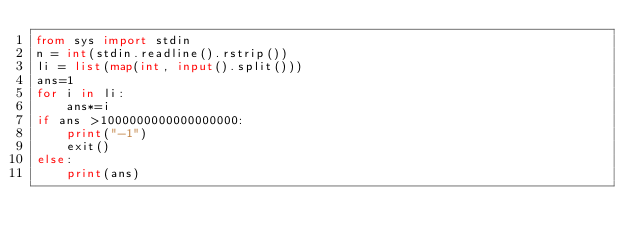<code> <loc_0><loc_0><loc_500><loc_500><_Python_>from sys import stdin
n = int(stdin.readline().rstrip())
li = list(map(int, input().split()))
ans=1
for i in li:
    ans*=i
if ans >1000000000000000000:
	print("-1")
    exit()
else:
	print(ans)
</code> 